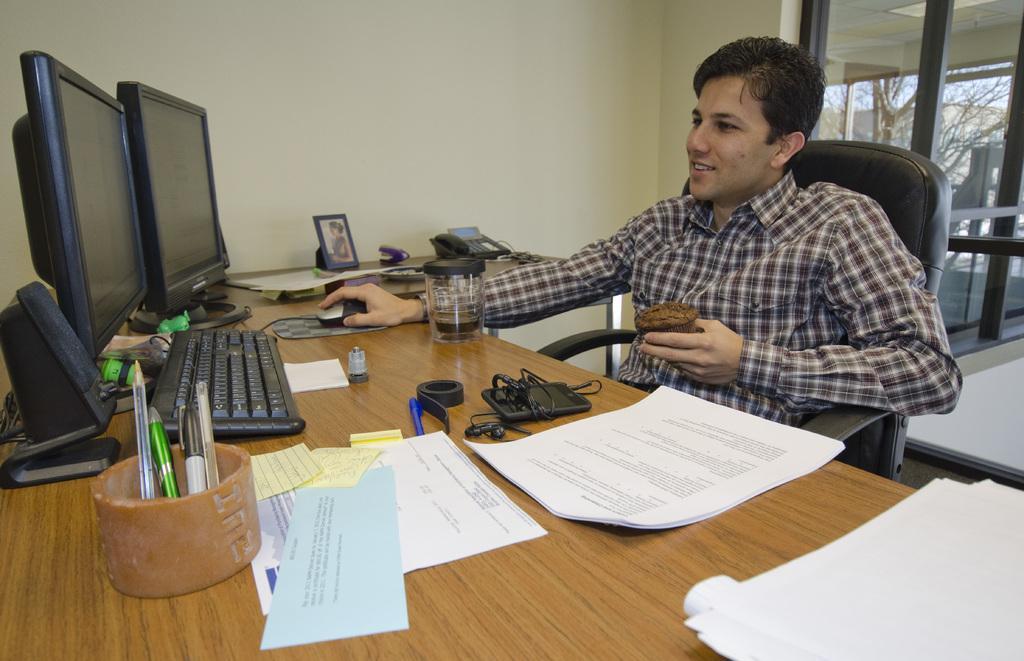Could you give a brief overview of what you see in this image? Here we can see one man sitting on chair in front of a table and he is holding a cupcake in his hand. And on the table we can see monitors, keyboards, speakers, pens, papers, mobile phone with headsets and a photo frame. on the background we can see wall. Through window glass we can see bare tree. 